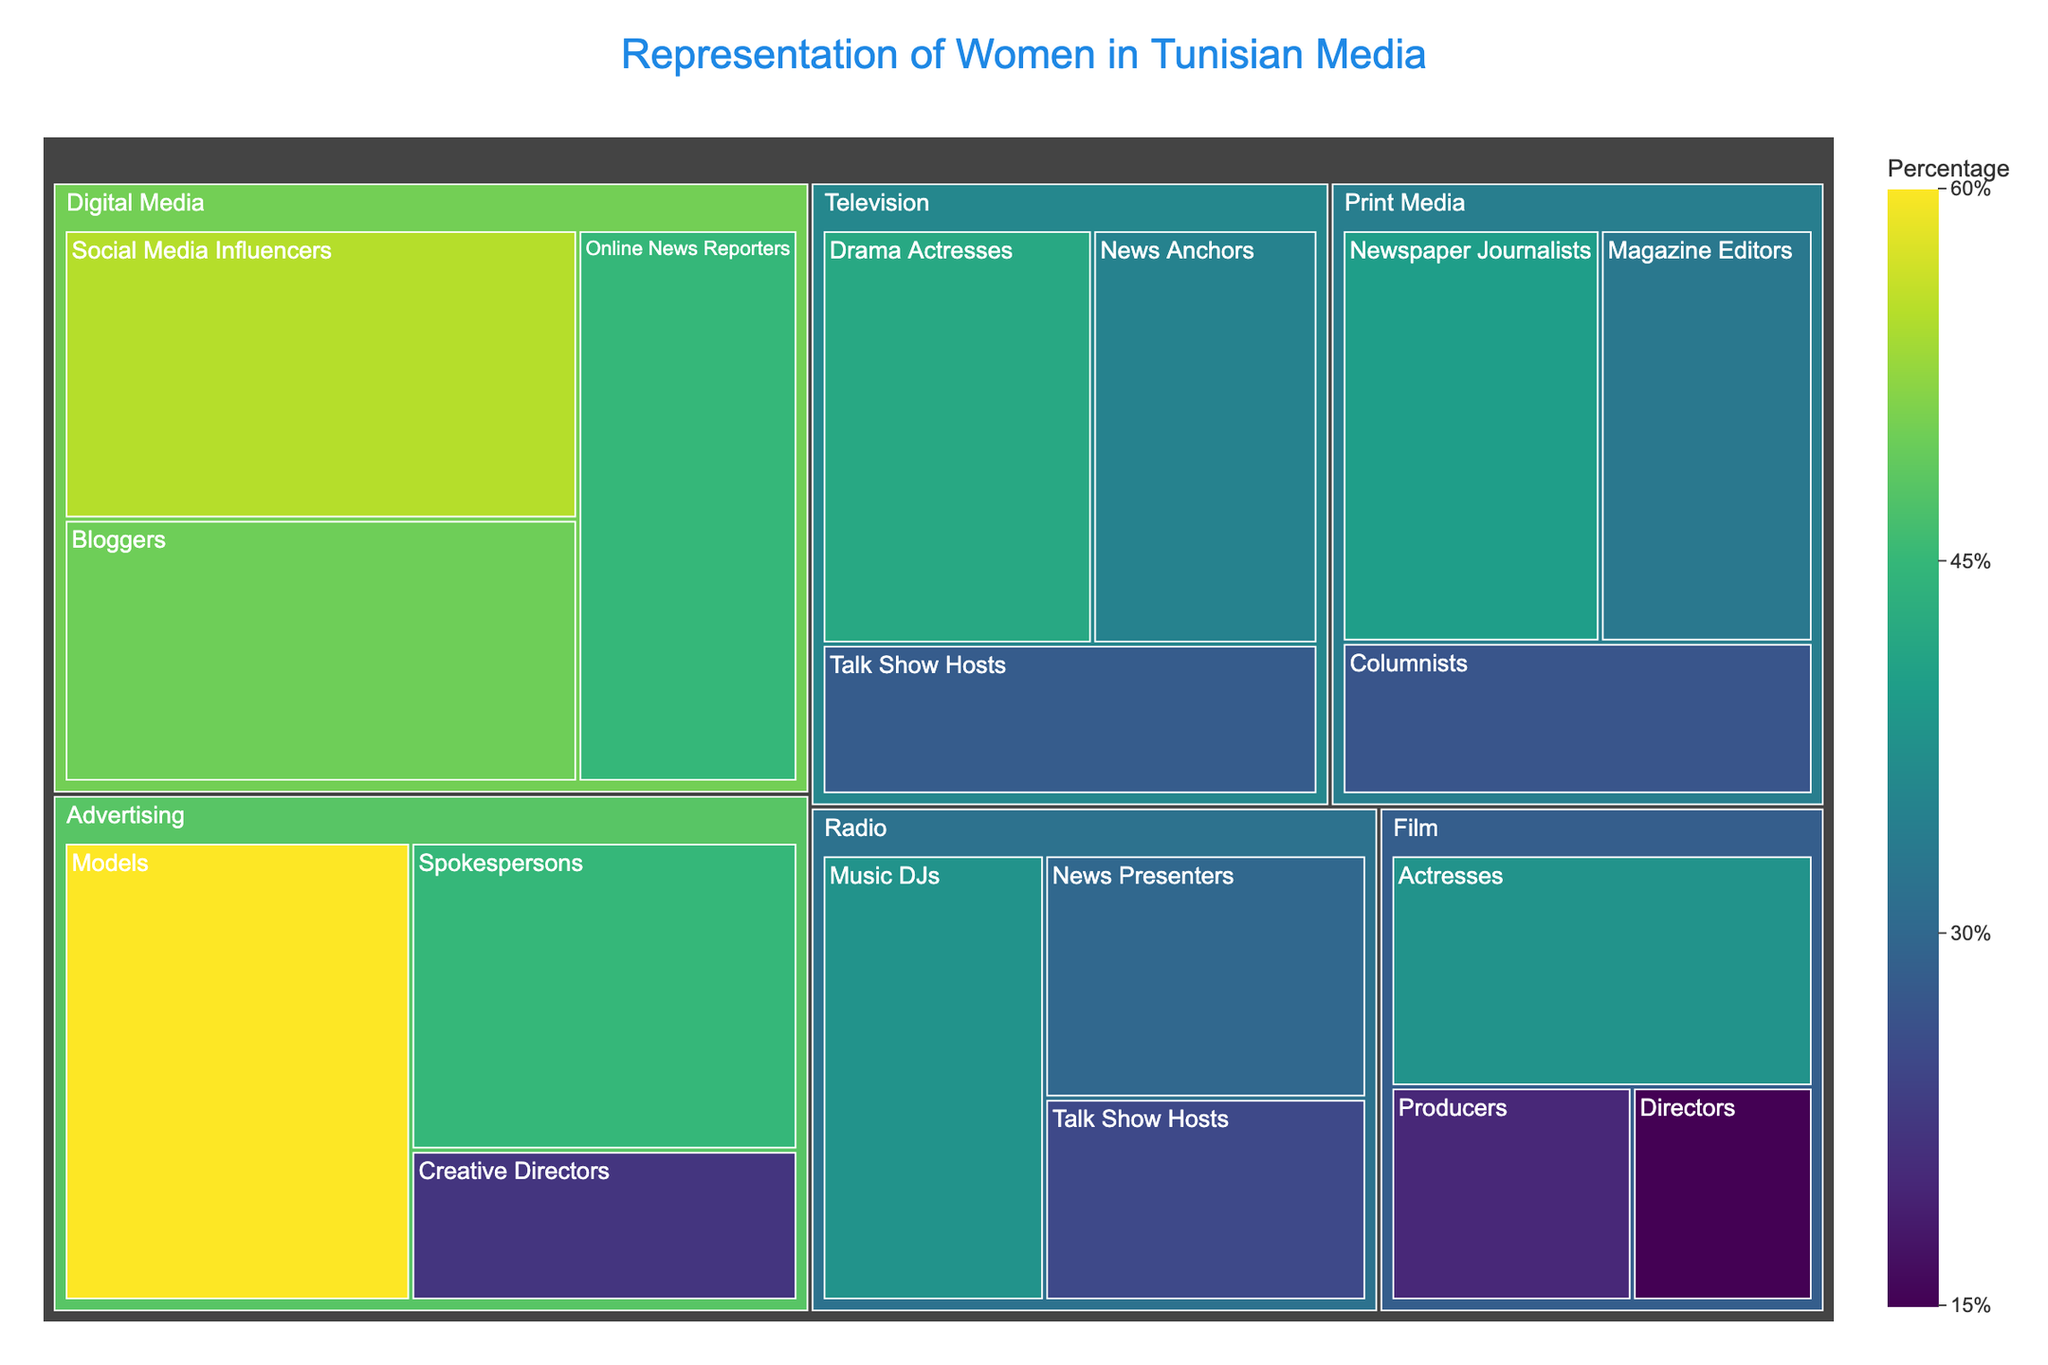What's the title of the treemap? The title of the treemap is located at the top of the plot, usually in larger and more prominent font. It provides an immediate understanding of the data being visualized.
Answer: Representation of Women in Tunisian Media Which category has the highest value in a subcategory? Review the subcategories and their corresponding values. The largest value corresponds to the subcategory under the "Advertising" category labeled "Models".
Answer: Advertising - Models How many subcategories are there in the "Digital Media" category? In the treemap, each category is divided into subcategories which can be easily counted under "Digital Media".
Answer: 3 What is the combined value of all subcategories under "Film"? Add up the values of each subcategory under "Film": Actresses (38), Directors (15), and Producers (20). The combined value is the total of these.
Answer: 73 Which subcategory in "Radio" has the smallest representation of women? Identify the values associated with each subcategory in "Radio" and find the minimum value. The smallest representation is associated with "Talk Show Hosts".
Answer: Talk Show Hosts What is the difference in value between "Television" News Anchors and "Print Media" Columnists? Subtract the value of "Print Media" Columnists (27) from the value of "Television" News Anchors (35).
Answer: 8 Which category or subcategory relies most heavily on visual representation? Identify categories or subcategories closely associated with visual representation. "Advertising - Models" has the highest associated value, highlighting its focus on visual representation.
Answer: Advertising - Models What is the total value for the "Television" category? Sum the values of all "Television" subcategories: News Anchors (35), Talk Show Hosts (28), and Drama Actresses (42).
Answer: 105 Are there more women Blogggers or Drama Actresses? Compare the values for "Digital Media - Bloggers" (50) and "Television - Drama Actresses" (42).
Answer: Bloggers Which subcategory has the highest value across all categories? Scan through all subcategories and their values, identifying the maximum value, which is under "Advertising - Models".
Answer: Advertising - Models 